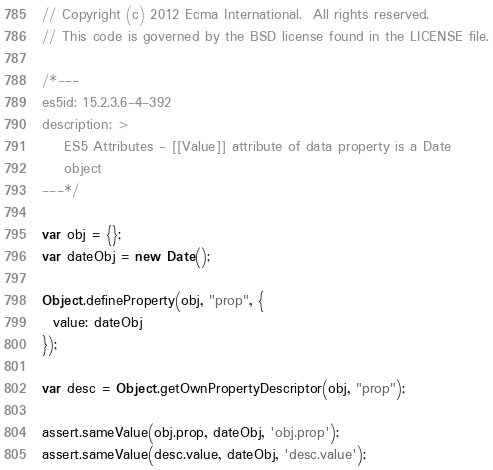Convert code to text. <code><loc_0><loc_0><loc_500><loc_500><_JavaScript_>// Copyright (c) 2012 Ecma International.  All rights reserved.
// This code is governed by the BSD license found in the LICENSE file.

/*---
es5id: 15.2.3.6-4-392
description: >
    ES5 Attributes - [[Value]] attribute of data property is a Date
    object
---*/

var obj = {};
var dateObj = new Date();

Object.defineProperty(obj, "prop", {
  value: dateObj
});

var desc = Object.getOwnPropertyDescriptor(obj, "prop");

assert.sameValue(obj.prop, dateObj, 'obj.prop');
assert.sameValue(desc.value, dateObj, 'desc.value');
</code> 